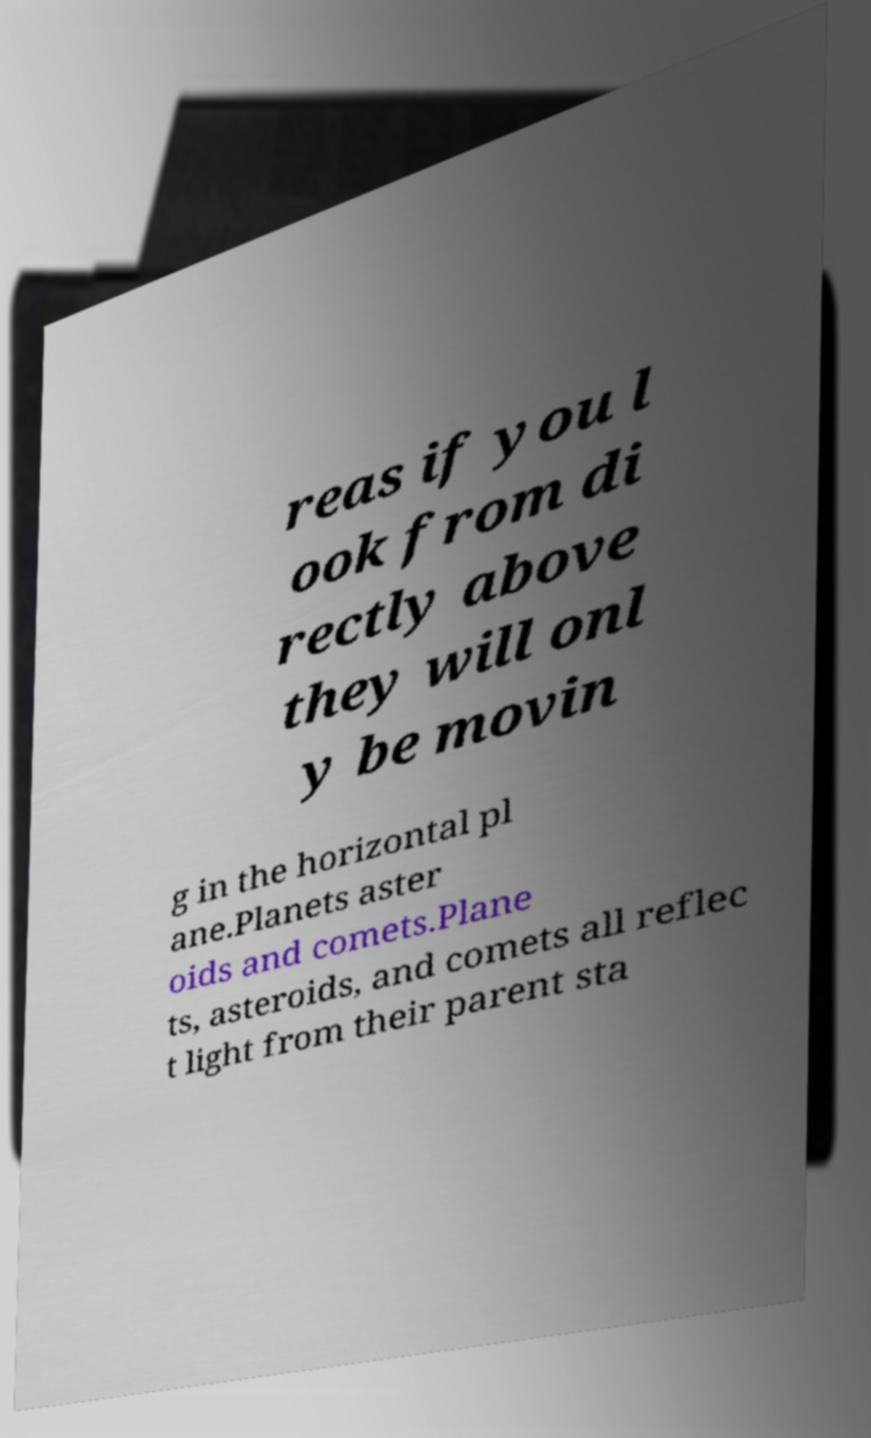There's text embedded in this image that I need extracted. Can you transcribe it verbatim? reas if you l ook from di rectly above they will onl y be movin g in the horizontal pl ane.Planets aster oids and comets.Plane ts, asteroids, and comets all reflec t light from their parent sta 